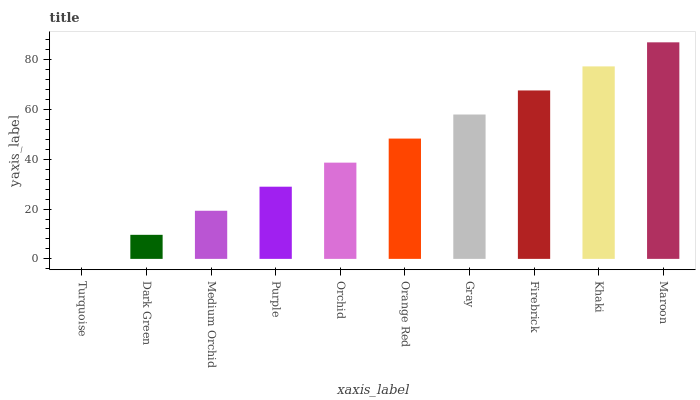Is Turquoise the minimum?
Answer yes or no. Yes. Is Maroon the maximum?
Answer yes or no. Yes. Is Dark Green the minimum?
Answer yes or no. No. Is Dark Green the maximum?
Answer yes or no. No. Is Dark Green greater than Turquoise?
Answer yes or no. Yes. Is Turquoise less than Dark Green?
Answer yes or no. Yes. Is Turquoise greater than Dark Green?
Answer yes or no. No. Is Dark Green less than Turquoise?
Answer yes or no. No. Is Orange Red the high median?
Answer yes or no. Yes. Is Orchid the low median?
Answer yes or no. Yes. Is Turquoise the high median?
Answer yes or no. No. Is Gray the low median?
Answer yes or no. No. 